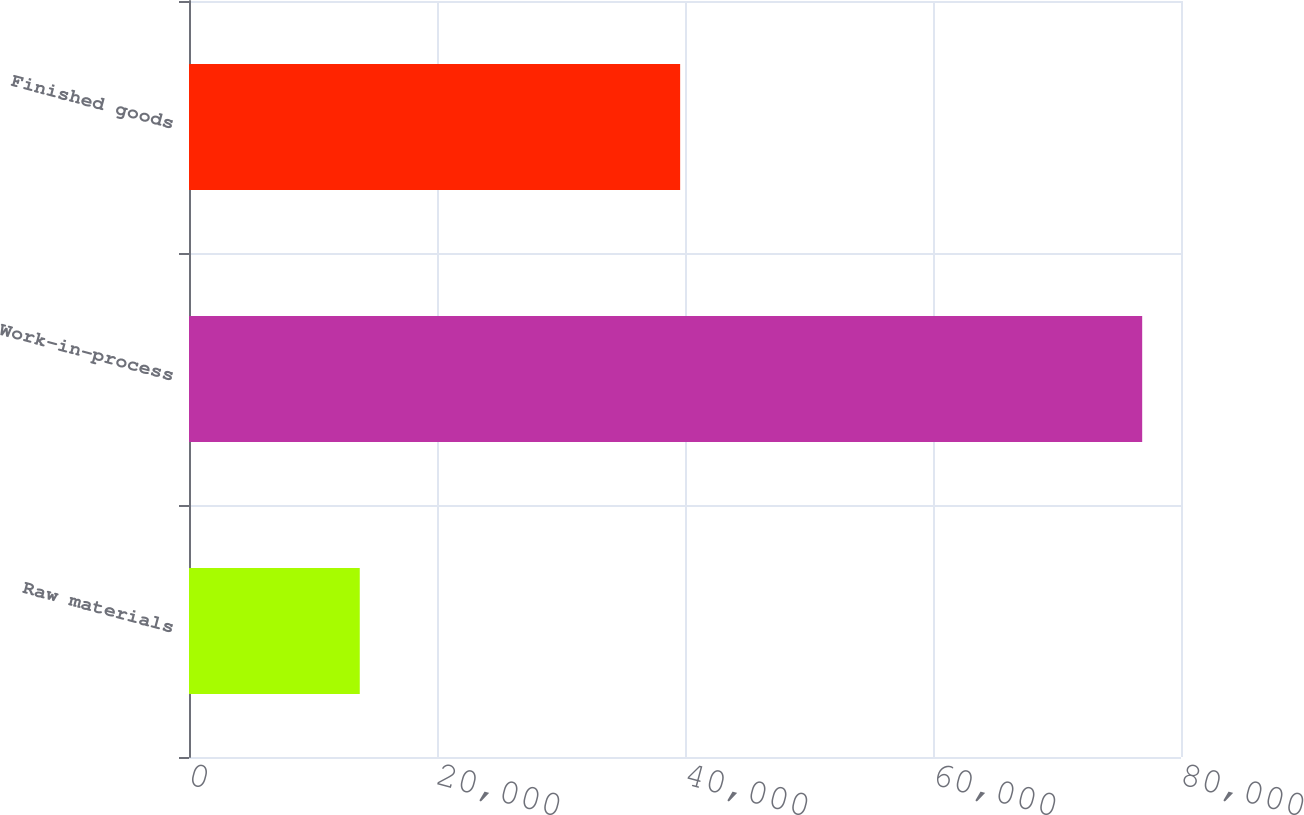<chart> <loc_0><loc_0><loc_500><loc_500><bar_chart><fcel>Raw materials<fcel>Work-in-process<fcel>Finished goods<nl><fcel>13771<fcel>76870<fcel>39609<nl></chart> 